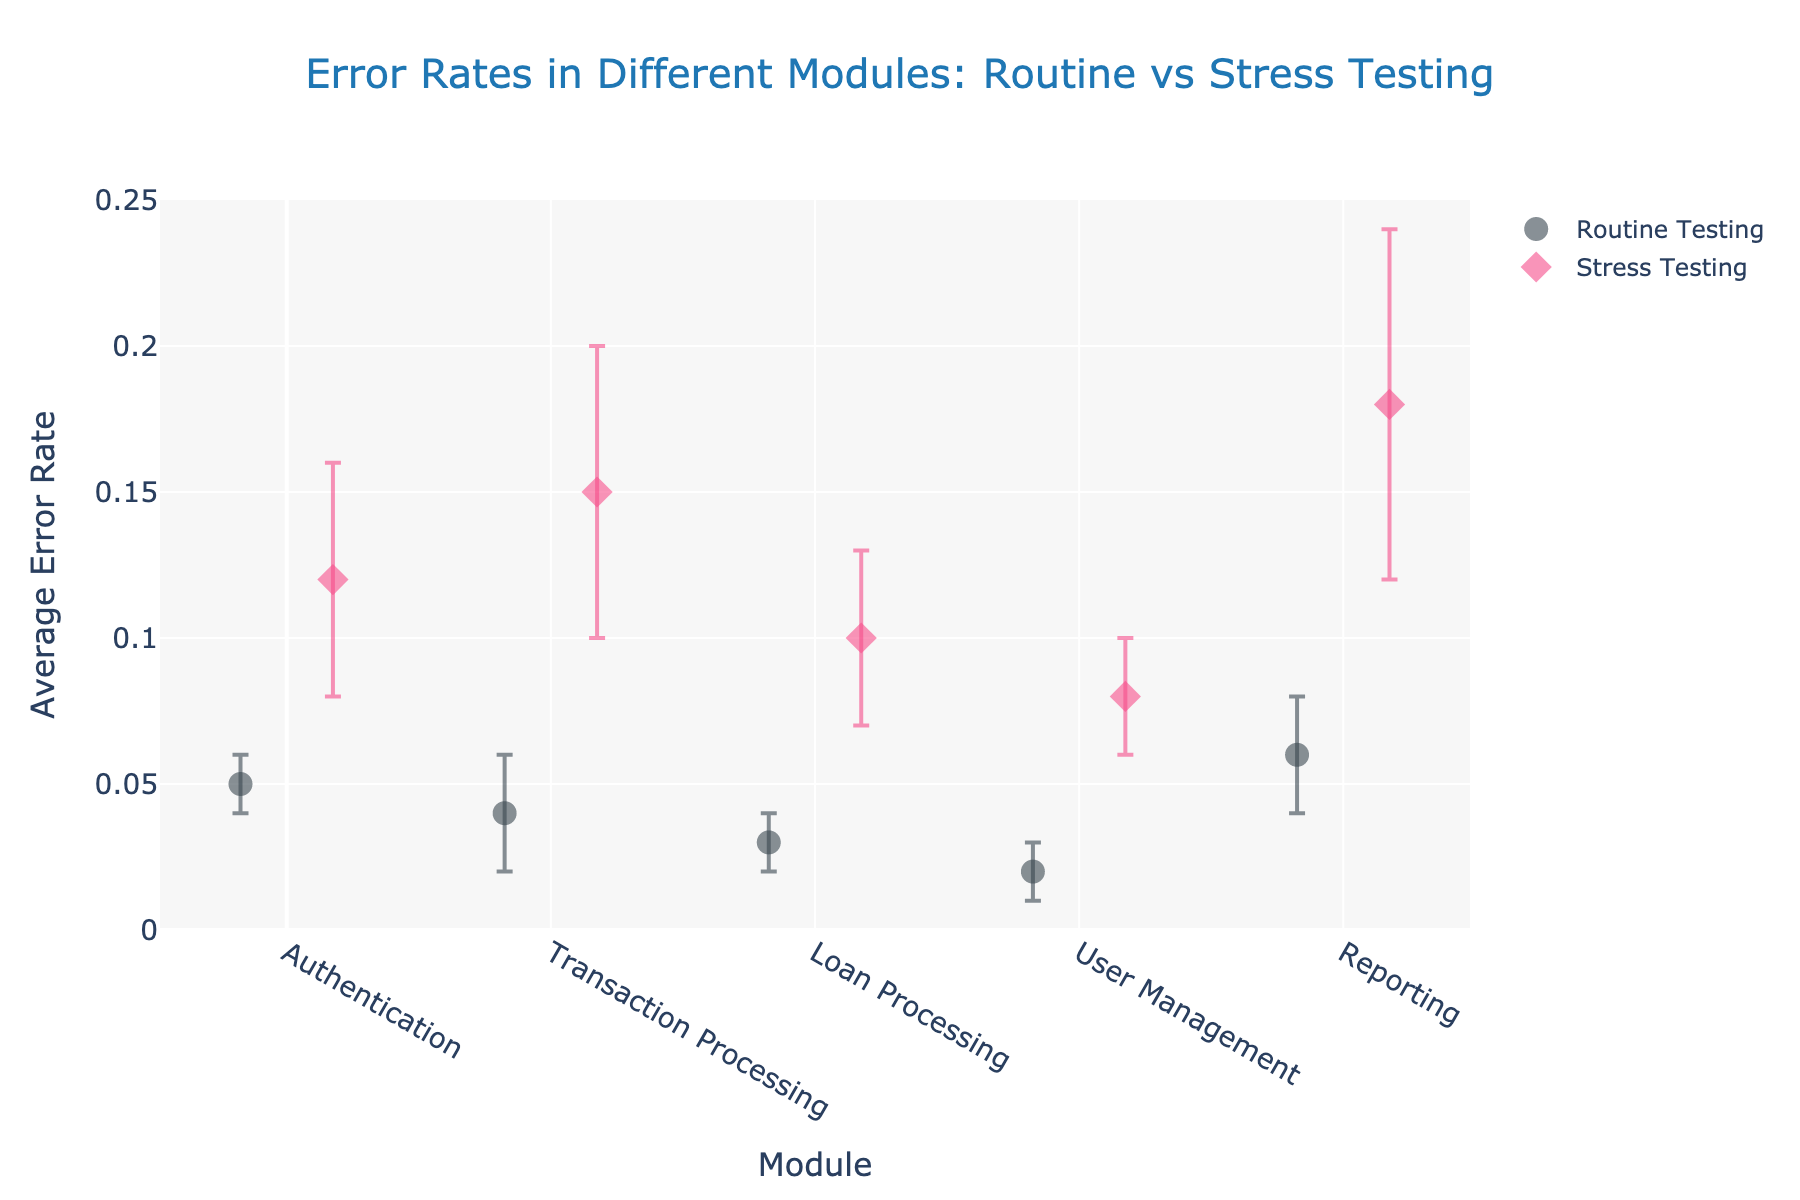What's the title of the plot? The title is located at the top of the plot and provides a summary of the information presented. In this case, it indicates the focus is on error rates during routine and stress testing across different modules.
Answer: Error Rates in Different Modules: Routine vs Stress Testing Which module has the highest error rate during routine testing? Look at the y-values of the markers labeled "Routine Testing" for each module and identify the one with the greatest value. The "Reporting" module stands out as the highest.
Answer: Reporting What is the approximate error rate for the Authentication module during stress testing? Find the Authentication module along the x-axis and refer to the y-value of the marker corresponding to "Stress Testing". The error rate is just below 0.15.
Answer: 0.12 How much higher is the error rate of the Reporting module during stress testing compared to routine testing? Look at the y-values for the "Reporting" module for both testing scenarios. Subtract the routine testing error rate from the stress testing error rate. (0.18 - 0.06 = 0.12)
Answer: 0.12 Which module has the lowest error rate during stress testing? Find the y-values of the markers labeled "Stress Testing" and identify the lowest one. The "User Management" module shows this lowest error rate.
Answer: User Management What is the error rate difference between routine and stress testing for the Transaction Processing module? Identify the y-values of the markers for both testing scenarios in the Transaction Processing module and subtract them. (0.15 - 0.04 = 0.11)
Answer: 0.11 Which testing scenario generally shows higher error rates? Compare the height of markers for routine vs. stress testing across modules. Stress testing consistently shows higher error rates.
Answer: Stress Testing For the Loan Processing module, what are the error rates for routine and stress testing, and what is the difference between them? Locate the Loan Processing module markers, read off the y-values for both scenarios, then subtract the routine error rate from the stress error rate. (Stress: 0.10, Routine: 0.03, Difference: 0.10 - 0.03 = 0.07)
Answer: Stress: 0.10, Routine: 0.03, Difference: 0.07 